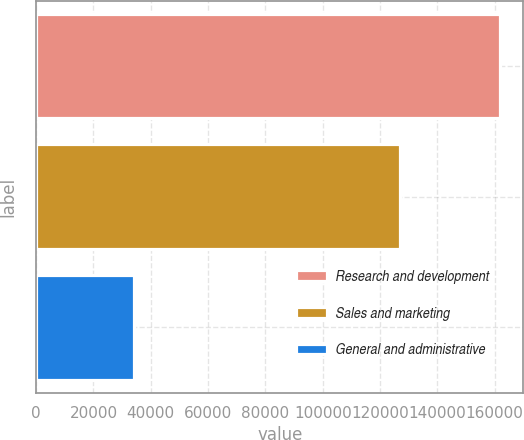<chart> <loc_0><loc_0><loc_500><loc_500><bar_chart><fcel>Research and development<fcel>Sales and marketing<fcel>General and administrative<nl><fcel>161891<fcel>126803<fcel>34263<nl></chart> 